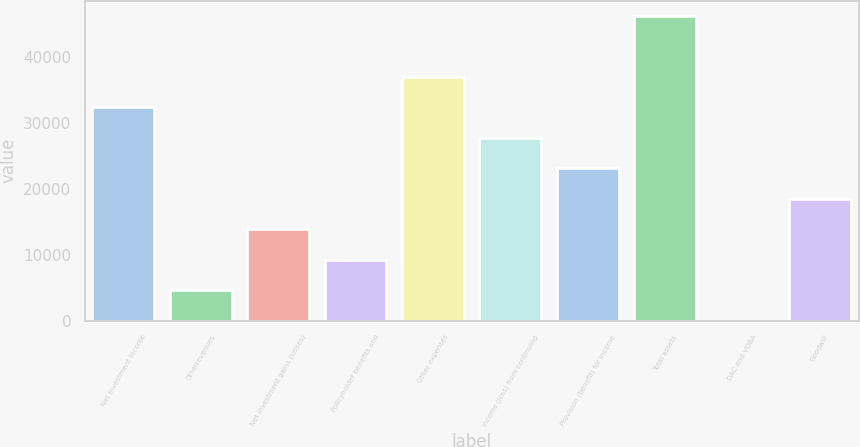Convert chart. <chart><loc_0><loc_0><loc_500><loc_500><bar_chart><fcel>Net investment income<fcel>Otherrevenues<fcel>Net investment gains (losses)<fcel>Policyholder benefits and<fcel>Other expenses<fcel>Income (loss) from continuing<fcel>Provision (benefit) for income<fcel>Total assets<fcel>DAC and VOBA<fcel>Goodwill<nl><fcel>32301.2<fcel>4625.6<fcel>13850.8<fcel>9238.2<fcel>36913.8<fcel>27688.6<fcel>23076<fcel>46139<fcel>13<fcel>18463.4<nl></chart> 